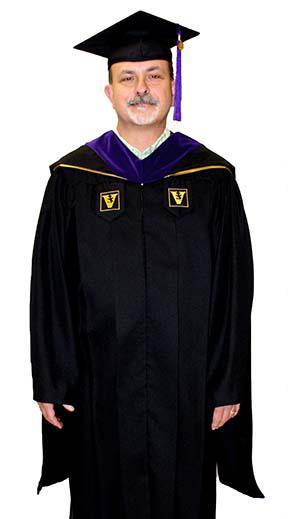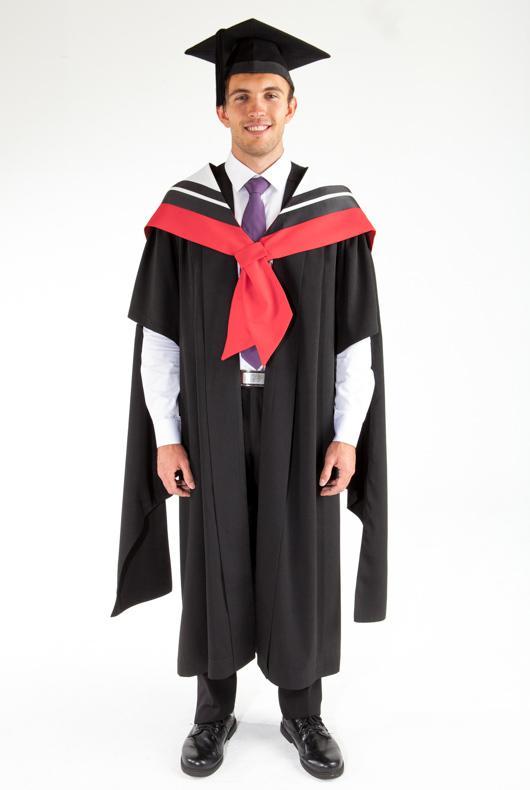The first image is the image on the left, the second image is the image on the right. Considering the images on both sides, is "There is a female in the right image." valid? Answer yes or no. No. The first image is the image on the left, the second image is the image on the right. For the images shown, is this caption "There is a man on the left and a woman on the right in both images." true? Answer yes or no. No. 